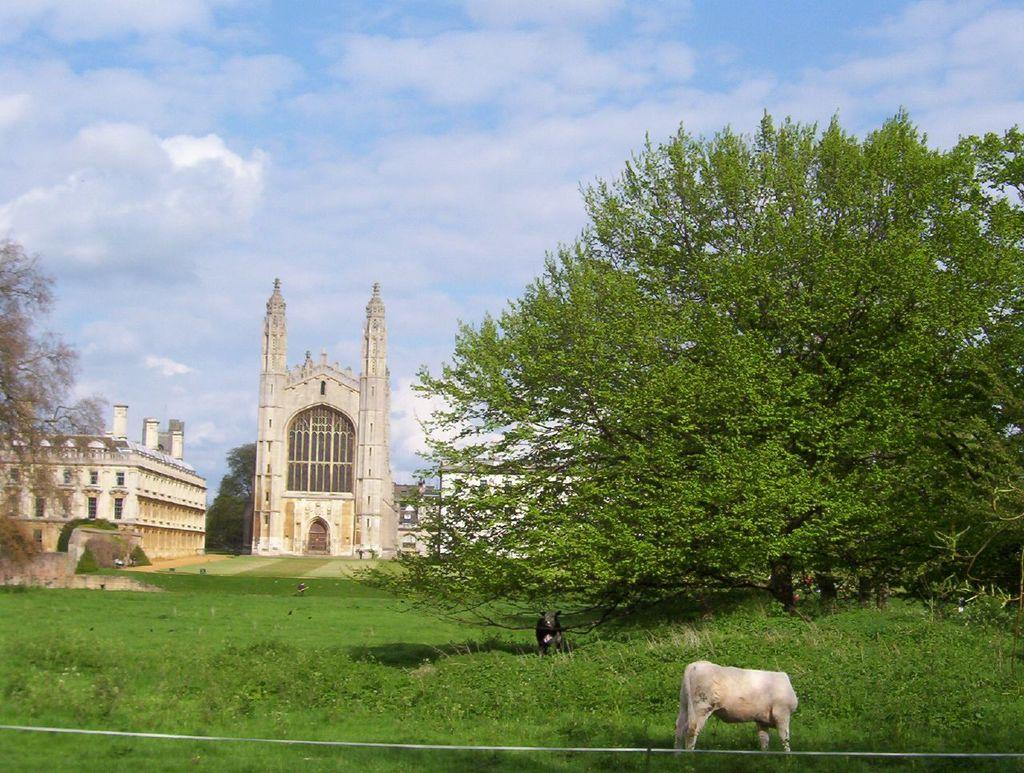What type of structure is the main subject of the image? There is a castle in the image. What other structures can be seen in the image? There are buildings in the image. What type of vegetation is present in the image? There are trees in the image. What type of animals can be seen in the image? There are animals in the image. What type of ground surface is visible in the image? There is grass in the image. What is visible in the sky in the image? The sky is visible in the image, and clouds are present. What is the rope visible at the bottom of the image used for? The purpose of the rope is not mentioned in the facts provided. What type of juice is being served in the image? There is no mention of juice in the image. What is the castle pointing towards in the image? The castle is not pointing towards anything in the image. 